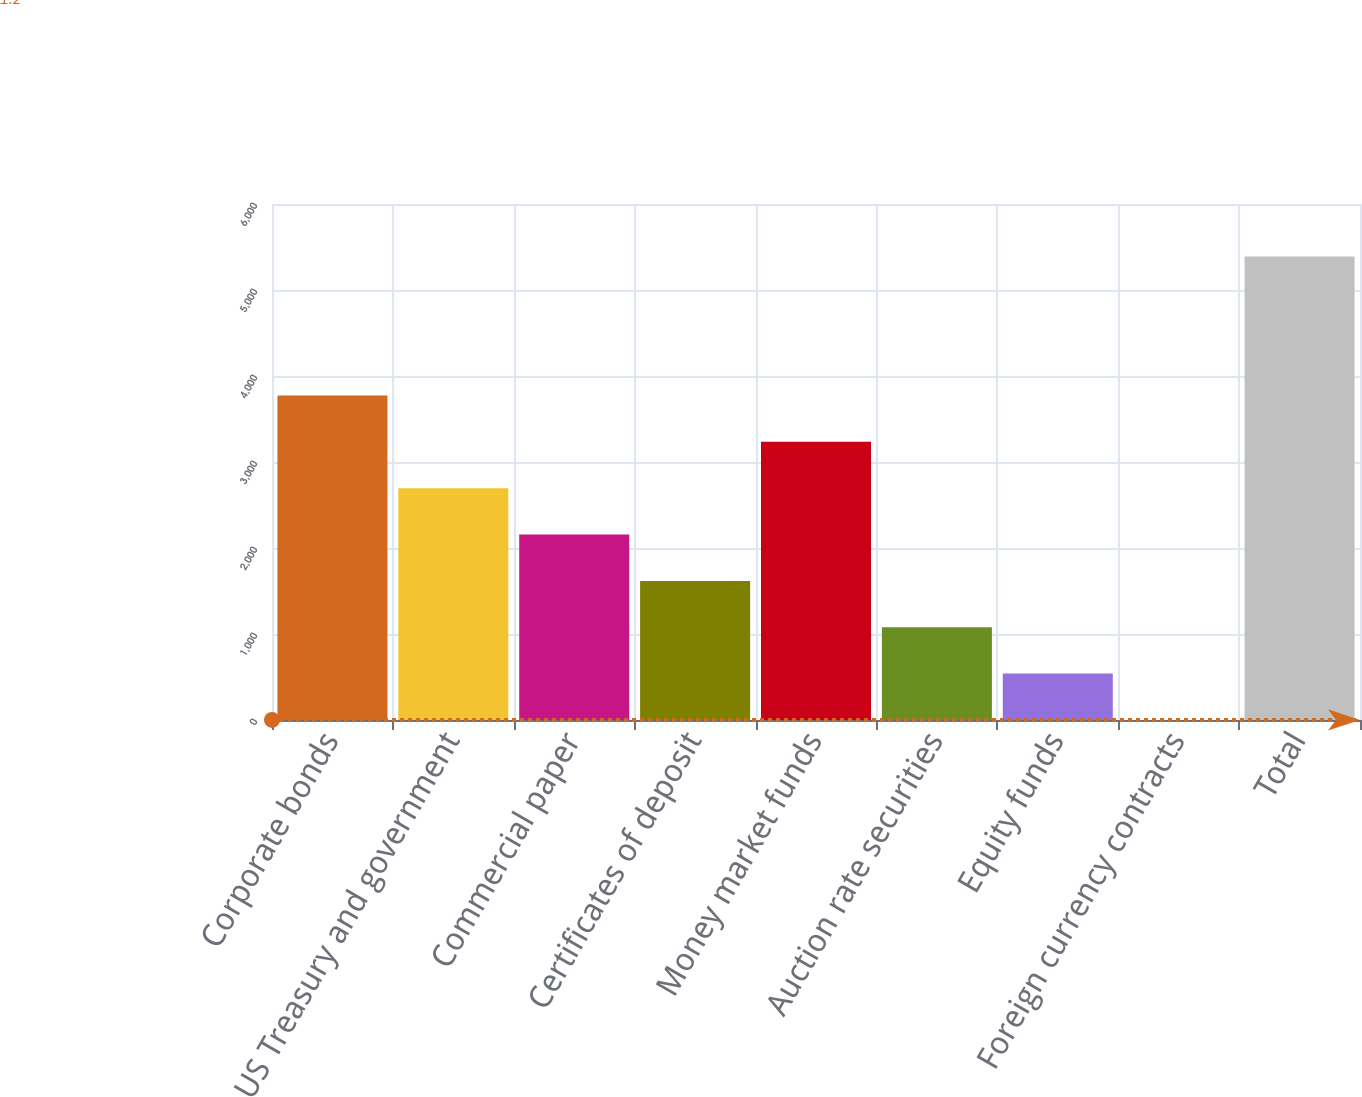Convert chart. <chart><loc_0><loc_0><loc_500><loc_500><bar_chart><fcel>Corporate bonds<fcel>US Treasury and government<fcel>Commercial paper<fcel>Certificates of deposit<fcel>Money market funds<fcel>Auction rate securities<fcel>Equity funds<fcel>Foreign currency contracts<fcel>Total<nl><fcel>3772.94<fcel>2695.3<fcel>2156.48<fcel>1617.66<fcel>3234.12<fcel>1078.84<fcel>540.02<fcel>1.2<fcel>5389.4<nl></chart> 